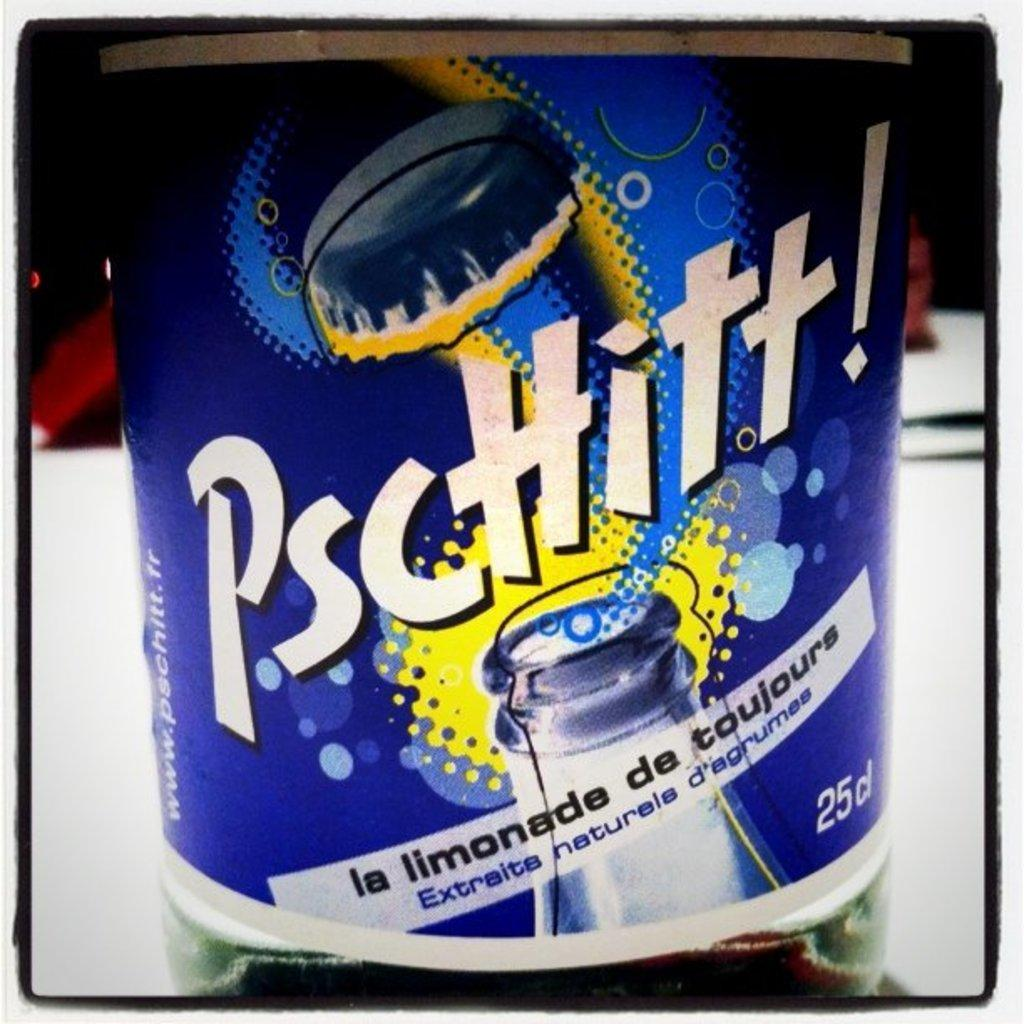<image>
Present a compact description of the photo's key features. A bottle of some type of beverage with the text, Pscttitt!, written on the front. 